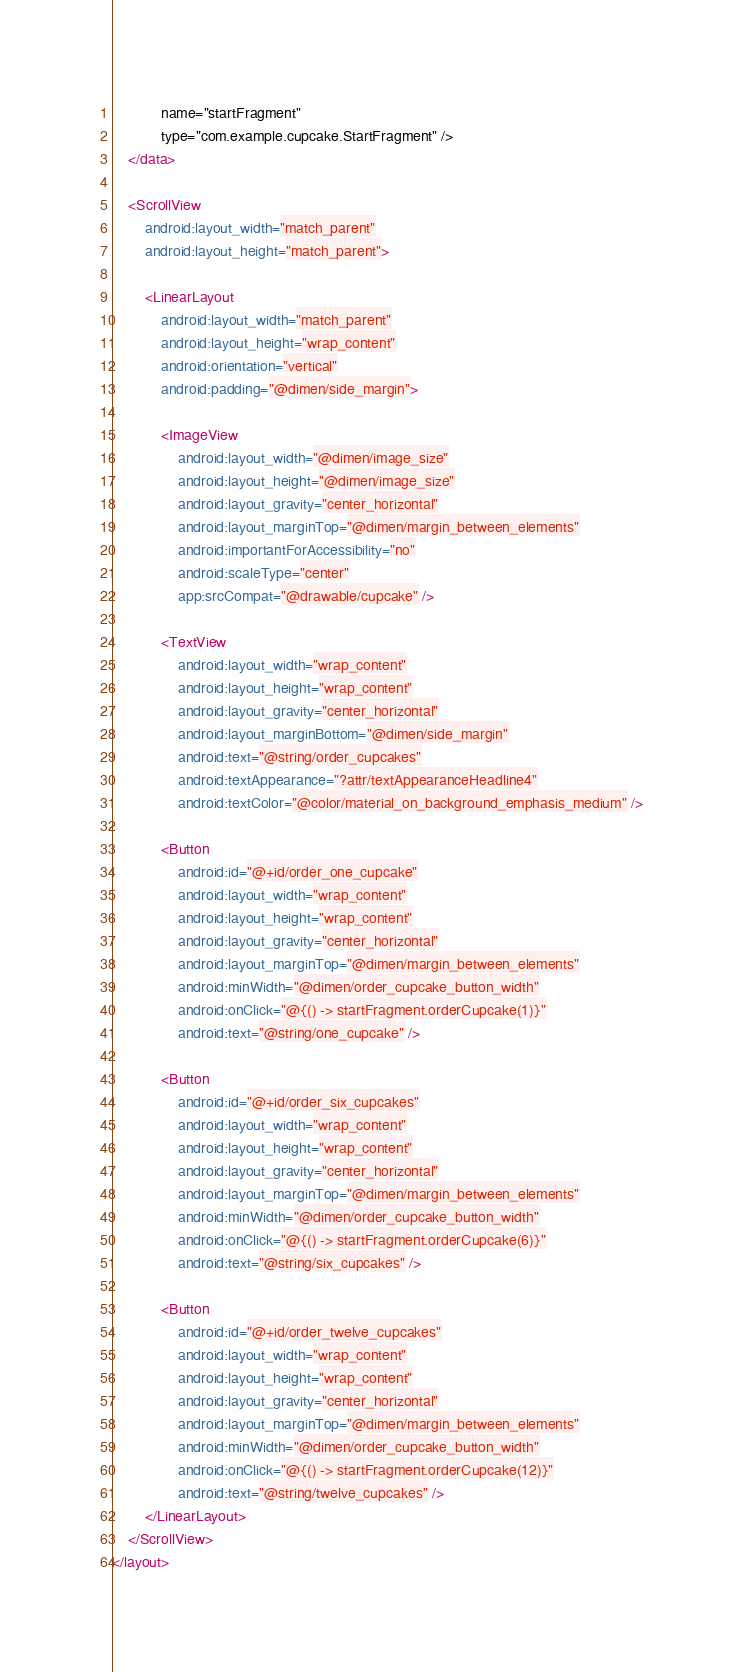<code> <loc_0><loc_0><loc_500><loc_500><_XML_>            name="startFragment"
            type="com.example.cupcake.StartFragment" />
    </data>

    <ScrollView
        android:layout_width="match_parent"
        android:layout_height="match_parent">

        <LinearLayout
            android:layout_width="match_parent"
            android:layout_height="wrap_content"
            android:orientation="vertical"
            android:padding="@dimen/side_margin">

            <ImageView
                android:layout_width="@dimen/image_size"
                android:layout_height="@dimen/image_size"
                android:layout_gravity="center_horizontal"
                android:layout_marginTop="@dimen/margin_between_elements"
                android:importantForAccessibility="no"
                android:scaleType="center"
                app:srcCompat="@drawable/cupcake" />

            <TextView
                android:layout_width="wrap_content"
                android:layout_height="wrap_content"
                android:layout_gravity="center_horizontal"
                android:layout_marginBottom="@dimen/side_margin"
                android:text="@string/order_cupcakes"
                android:textAppearance="?attr/textAppearanceHeadline4"
                android:textColor="@color/material_on_background_emphasis_medium" />

            <Button
                android:id="@+id/order_one_cupcake"
                android:layout_width="wrap_content"
                android:layout_height="wrap_content"
                android:layout_gravity="center_horizontal"
                android:layout_marginTop="@dimen/margin_between_elements"
                android:minWidth="@dimen/order_cupcake_button_width"
                android:onClick="@{() -> startFragment.orderCupcake(1)}"
                android:text="@string/one_cupcake" />

            <Button
                android:id="@+id/order_six_cupcakes"
                android:layout_width="wrap_content"
                android:layout_height="wrap_content"
                android:layout_gravity="center_horizontal"
                android:layout_marginTop="@dimen/margin_between_elements"
                android:minWidth="@dimen/order_cupcake_button_width"
                android:onClick="@{() -> startFragment.orderCupcake(6)}"
                android:text="@string/six_cupcakes" />

            <Button
                android:id="@+id/order_twelve_cupcakes"
                android:layout_width="wrap_content"
                android:layout_height="wrap_content"
                android:layout_gravity="center_horizontal"
                android:layout_marginTop="@dimen/margin_between_elements"
                android:minWidth="@dimen/order_cupcake_button_width"
                android:onClick="@{() -> startFragment.orderCupcake(12)}"
                android:text="@string/twelve_cupcakes" />
        </LinearLayout>
    </ScrollView>
</layout></code> 